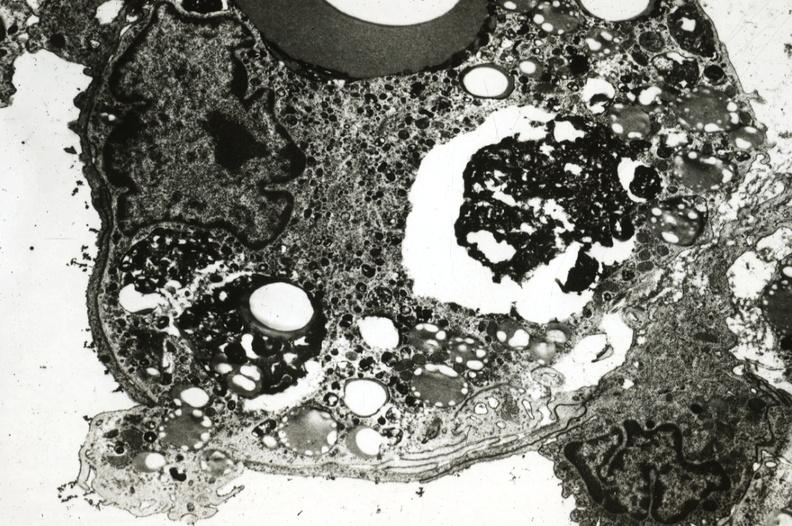s cardiovascular present?
Answer the question using a single word or phrase. Yes 